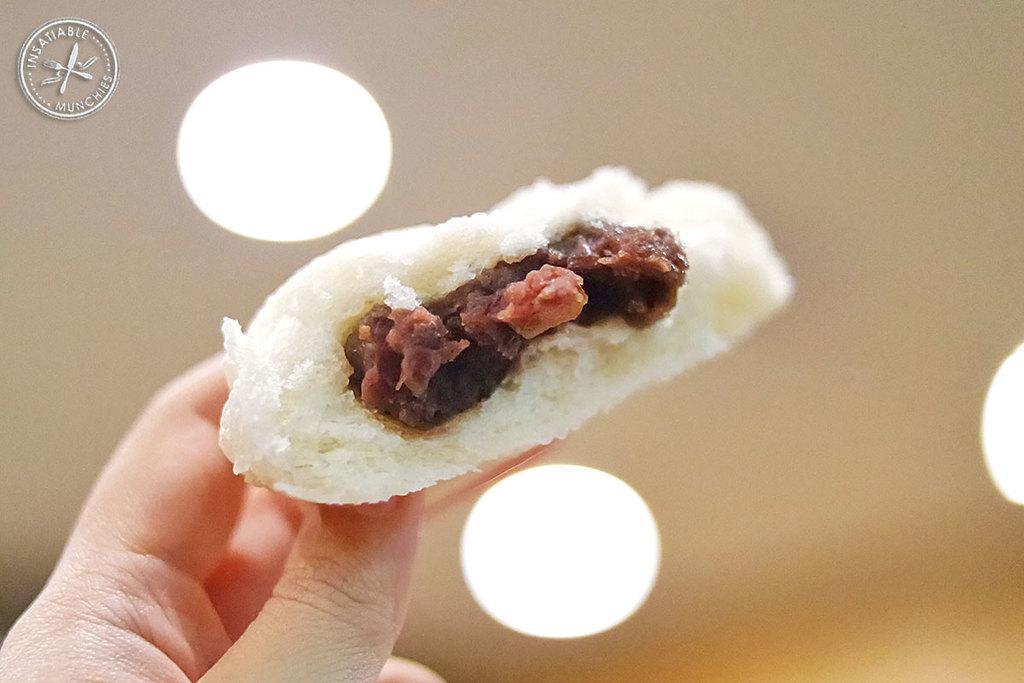Can you describe this image briefly? In this picture we can see a human hand holding a food item. There are some lights. We can see a logo in the top left. Background is blurry. 